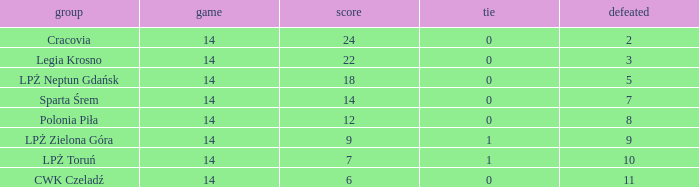What is the highest loss with points less than 7? 11.0. 